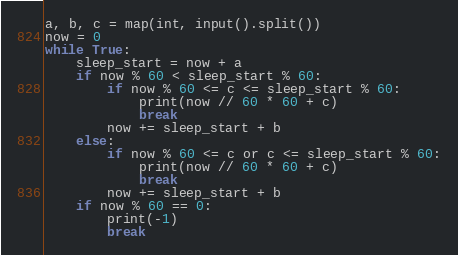<code> <loc_0><loc_0><loc_500><loc_500><_Python_>a, b, c = map(int, input().split())
now = 0
while True:
    sleep_start = now + a
    if now % 60 < sleep_start % 60:
        if now % 60 <= c <= sleep_start % 60:
            print(now // 60 * 60 + c)
            break
        now += sleep_start + b
    else:
        if now % 60 <= c or c <= sleep_start % 60:
            print(now // 60 * 60 + c)
            break
        now += sleep_start + b
    if now % 60 == 0:
        print(-1)
        break</code> 